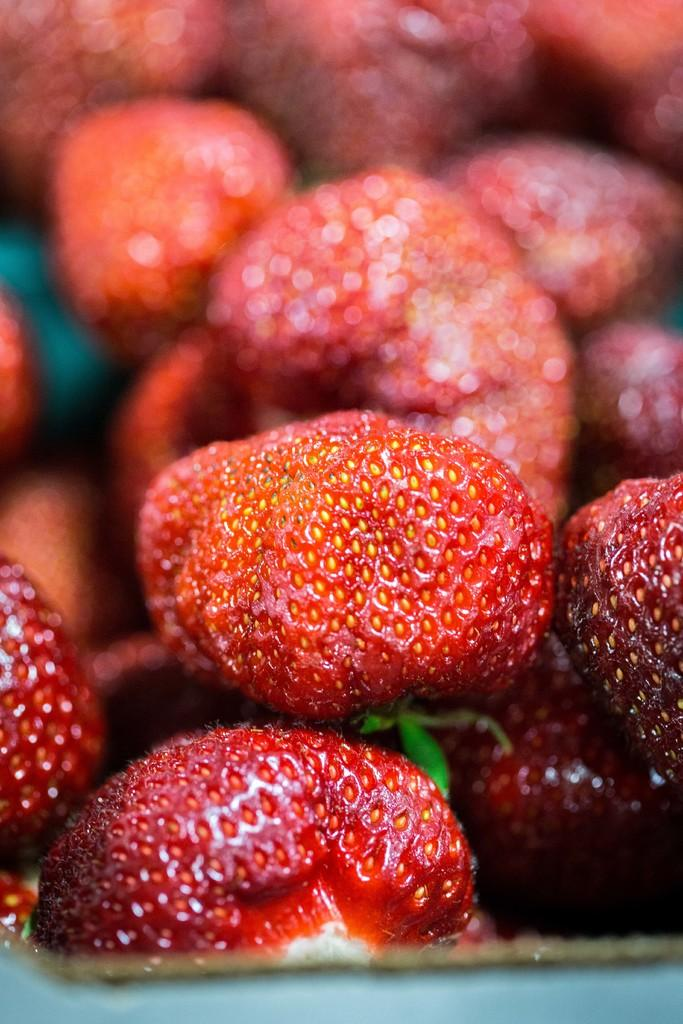What is the main subject of the image? The main subject of the image is a zoomed in picture of strawberries. Can you describe the appearance of the strawberries in the image? The strawberries appear to be fresh and ripe, with their characteristic red color and green leaves. What type of knee injury can be seen in the image? There is no knee injury present in the image, as it is a zoomed in picture of strawberries. Is there an alarm clock visible in the image? There is no alarm clock present in the image, as it is a zoomed in picture of strawberries. 